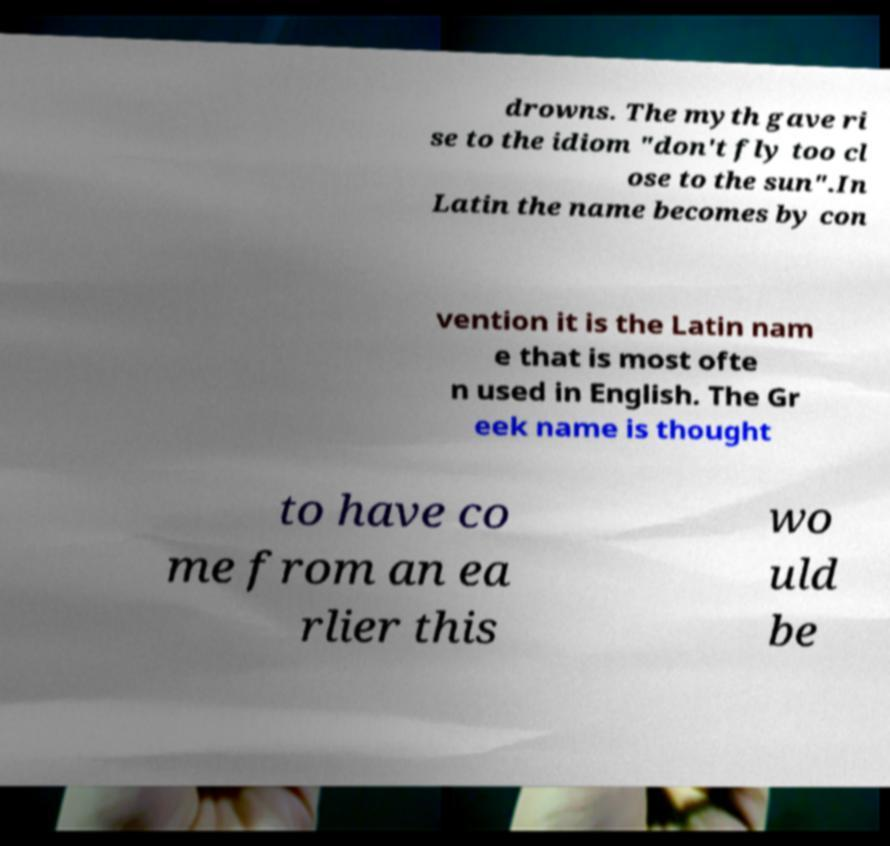Please read and relay the text visible in this image. What does it say? drowns. The myth gave ri se to the idiom "don't fly too cl ose to the sun".In Latin the name becomes by con vention it is the Latin nam e that is most ofte n used in English. The Gr eek name is thought to have co me from an ea rlier this wo uld be 